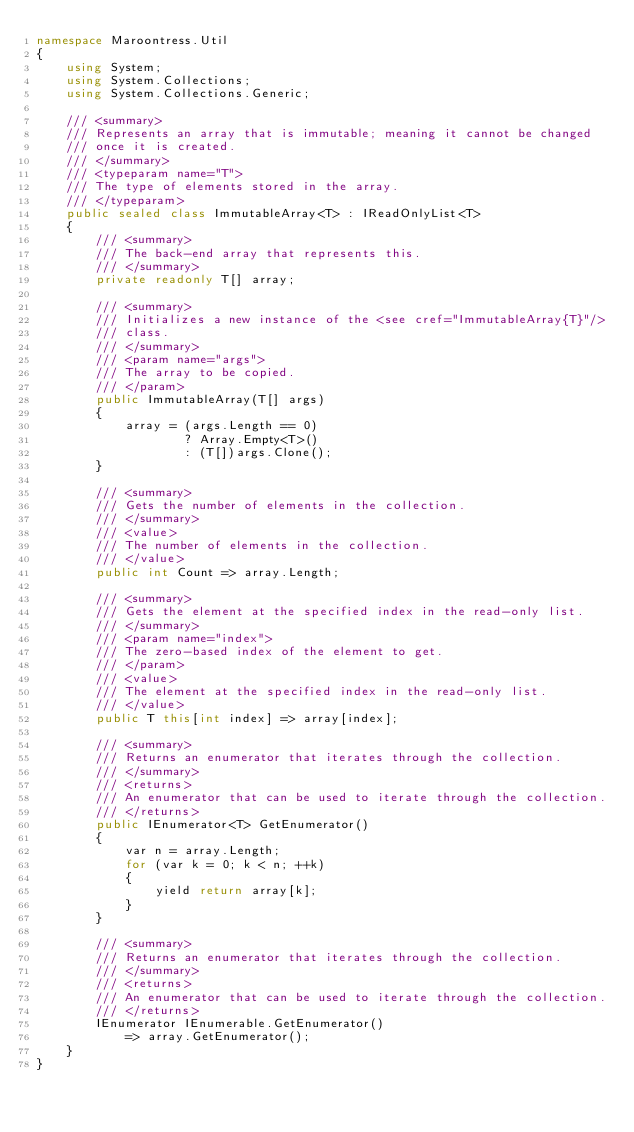<code> <loc_0><loc_0><loc_500><loc_500><_C#_>namespace Maroontress.Util
{
    using System;
    using System.Collections;
    using System.Collections.Generic;

    /// <summary>
    /// Represents an array that is immutable; meaning it cannot be changed
    /// once it is created.
    /// </summary>
    /// <typeparam name="T">
    /// The type of elements stored in the array.
    /// </typeparam>
    public sealed class ImmutableArray<T> : IReadOnlyList<T>
    {
        /// <summary>
        /// The back-end array that represents this.
        /// </summary>
        private readonly T[] array;

        /// <summary>
        /// Initializes a new instance of the <see cref="ImmutableArray{T}"/>
        /// class.
        /// </summary>
        /// <param name="args">
        /// The array to be copied.
        /// </param>
        public ImmutableArray(T[] args)
        {
            array = (args.Length == 0)
                    ? Array.Empty<T>()
                    : (T[])args.Clone();
        }

        /// <summary>
        /// Gets the number of elements in the collection.
        /// </summary>
        /// <value>
        /// The number of elements in the collection.
        /// </value>
        public int Count => array.Length;

        /// <summary>
        /// Gets the element at the specified index in the read-only list.
        /// </summary>
        /// <param name="index">
        /// The zero-based index of the element to get.
        /// </param>
        /// <value>
        /// The element at the specified index in the read-only list.
        /// </value>
        public T this[int index] => array[index];

        /// <summary>
        /// Returns an enumerator that iterates through the collection.
        /// </summary>
        /// <returns>
        /// An enumerator that can be used to iterate through the collection.
        /// </returns>
        public IEnumerator<T> GetEnumerator()
        {
            var n = array.Length;
            for (var k = 0; k < n; ++k)
            {
                yield return array[k];
            }
        }

        /// <summary>
        /// Returns an enumerator that iterates through the collection.
        /// </summary>
        /// <returns>
        /// An enumerator that can be used to iterate through the collection.
        /// </returns>
        IEnumerator IEnumerable.GetEnumerator()
            => array.GetEnumerator();
    }
}
</code> 